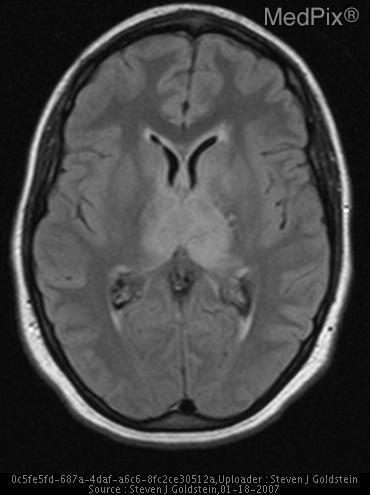Are the basal ganglia enlarged?
Give a very brief answer. No. Is there any hemorrhage?
Concise answer only. No. Is there involvement of the temporal lobes?
Answer briefly. No. 